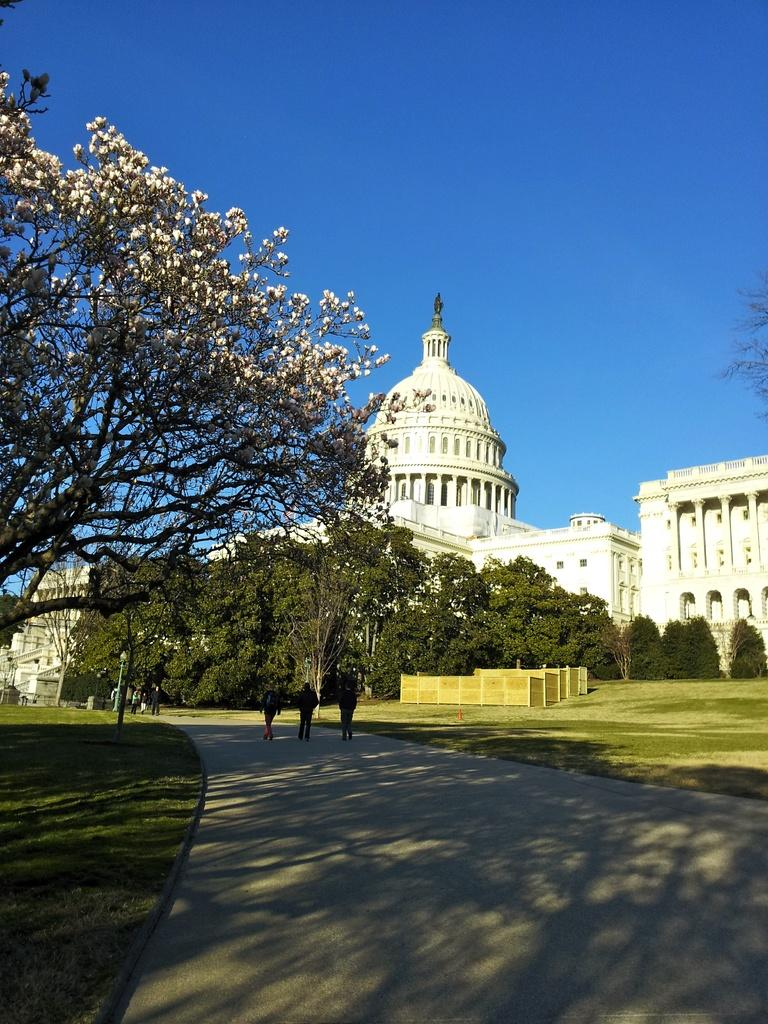What are the people in the image doing? The people in the image are walking. What type of vegetation can be seen in the image? There are trees in the image. What structures are located on the right side of the image? There are buildings on the right side of the image. What is visible at the top of the image? The sky is visible at the top of the image. What type of skin is visible on the trees in the image? The trees in the image do not have skin; they have bark. How can the buildings on the right side of the image be used? The image does not provide information on how the buildings can be used; it only shows their presence. 